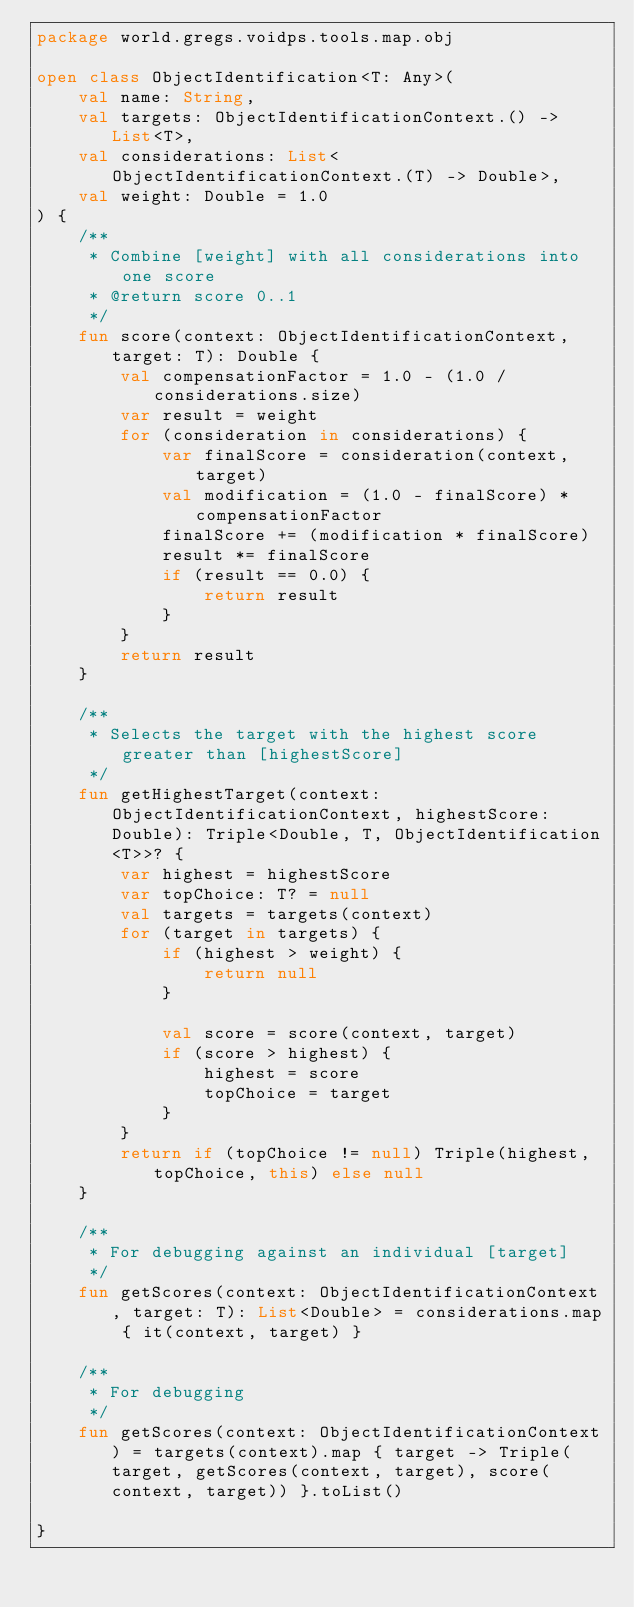<code> <loc_0><loc_0><loc_500><loc_500><_Kotlin_>package world.gregs.voidps.tools.map.obj

open class ObjectIdentification<T: Any>(
    val name: String,
    val targets: ObjectIdentificationContext.() -> List<T>,
    val considerations: List<ObjectIdentificationContext.(T) -> Double>,
    val weight: Double = 1.0
) {
    /**
     * Combine [weight] with all considerations into one score
     * @return score 0..1
     */
    fun score(context: ObjectIdentificationContext, target: T): Double {
        val compensationFactor = 1.0 - (1.0 / considerations.size)
        var result = weight
        for (consideration in considerations) {
            var finalScore = consideration(context, target)
            val modification = (1.0 - finalScore) * compensationFactor
            finalScore += (modification * finalScore)
            result *= finalScore
            if (result == 0.0) {
                return result
            }
        }
        return result
    }

    /**
     * Selects the target with the highest score greater than [highestScore]
     */
    fun getHighestTarget(context: ObjectIdentificationContext, highestScore: Double): Triple<Double, T, ObjectIdentification<T>>? {
        var highest = highestScore
        var topChoice: T? = null
        val targets = targets(context)
        for (target in targets) {
            if (highest > weight) {
                return null
            }

            val score = score(context, target)
            if (score > highest) {
                highest = score
                topChoice = target
            }
        }
        return if (topChoice != null) Triple(highest, topChoice, this) else null
    }

    /**
     * For debugging against an individual [target]
     */
    fun getScores(context: ObjectIdentificationContext, target: T): List<Double> = considerations.map { it(context, target) }

    /**
     * For debugging
     */
    fun getScores(context: ObjectIdentificationContext) = targets(context).map { target -> Triple(target, getScores(context, target), score(context, target)) }.toList()

}</code> 